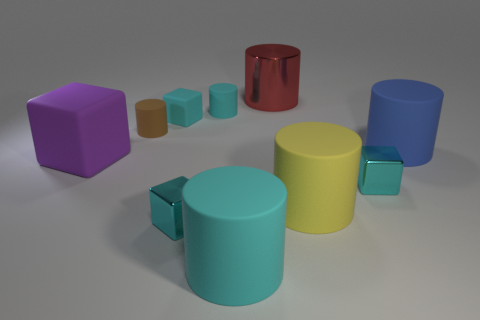What number of objects are purple matte blocks in front of the big red metal cylinder or things behind the big purple cube?
Your response must be concise. 6. Is the color of the tiny cylinder that is right of the tiny matte block the same as the matte cube on the right side of the big purple matte thing?
Make the answer very short. Yes. What is the shape of the big thing that is behind the large block and to the left of the large blue cylinder?
Your answer should be very brief. Cylinder. The rubber block that is the same size as the metallic cylinder is what color?
Offer a very short reply. Purple. Is there a large metal cylinder that has the same color as the big metal thing?
Your response must be concise. No. Do the matte block behind the big rubber block and the cyan rubber object that is in front of the large blue rubber cylinder have the same size?
Keep it short and to the point. No. There is a large thing that is both on the left side of the red metallic thing and right of the large purple rubber cube; what is its material?
Provide a short and direct response. Rubber. What number of other things are the same size as the blue cylinder?
Your answer should be very brief. 4. What material is the small cyan cube on the right side of the small cyan matte cylinder?
Your answer should be very brief. Metal. Is the yellow matte object the same shape as the large red shiny thing?
Provide a short and direct response. Yes. 